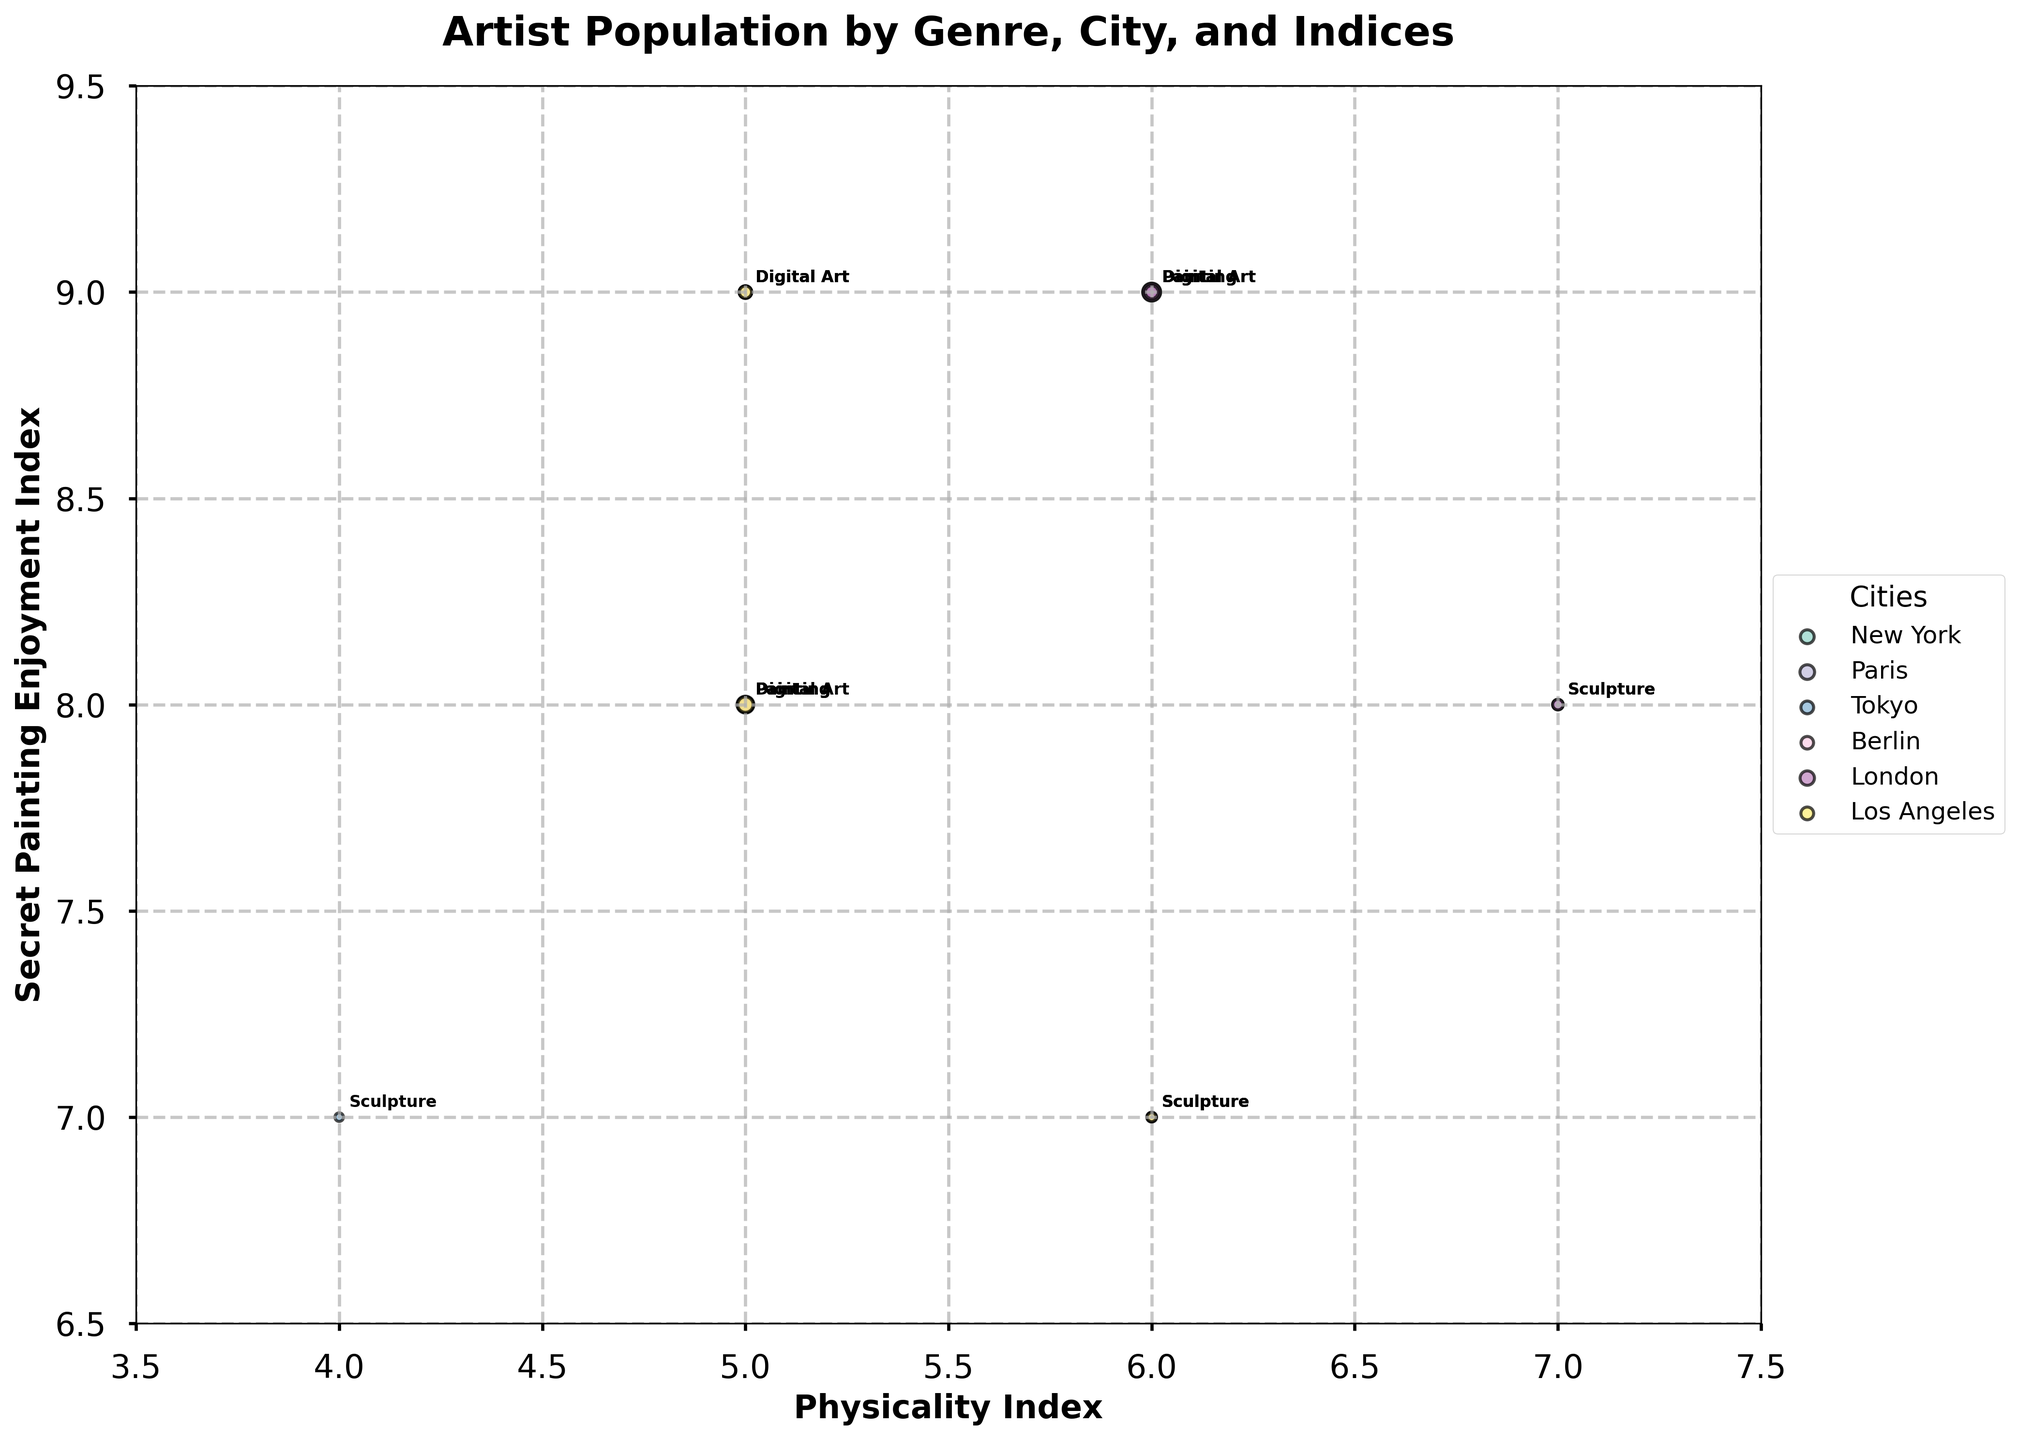Which city has the highest number of digital artists? Look at all the bubbles labeled "Digital Art" and compare their sizes. The largest bubble for Digital Art is in Tokyo.
Answer: Tokyo Which genre in Paris has the highest secret painting enjoyment index? Refer to the y-axis for Paris and compare the y-values of the genres. Digital Art and Painting both have a secret painting enjoyment index of 9.
Answer: Painting and Digital Art What's the name of the metric on the x-axis? Check the label on the x-axis. It's titled "Physicality Index".
Answer: Physicality Index How many genres are present in each city? Count the annotations within each distinct bubble cluster. There are three genres represented in each city.
Answer: 3 Which city has the smallest population of sculpture artists? Compare the sizes of the bubbles labeled "Sculpture" and identify the smallest one, which is in Tokyo.
Answer: Tokyo Which city has the highest physicality index for sculpture artists? Look at the x-values of the "Sculpture" bubbles across all cities. The highest x-value for Sculpture is in Paris.
Answer: Paris Compare the population of painting artists in New York and London. Which city has more painting artists? Look at the sizes of the bubbles labeled "Painting" for both New York and London and compare. London has the larger bubble.
Answer: London Which genre in Berlin has the highest physicality index? Refer to the x-axis for Berlin and compare the x-values of the genres. Sculpture has the highest physicality index of 6.
Answer: Sculpture What's the average secret painting enjoyment index for digital artists across all cities? Add the y-values for digital artists in all cities: (9 + 9 + 8 + 9 + 9 + 9) = 53. There are 6 cities, so the average is 53/6 = 8.83
Answer: 8.83 Which city has the most balanced population of artists across all genres? Compare the relative sizes of the bubbles in each city. Los Angeles has similar-sized bubbles for each genre compared to other cities.
Answer: Los Angeles 